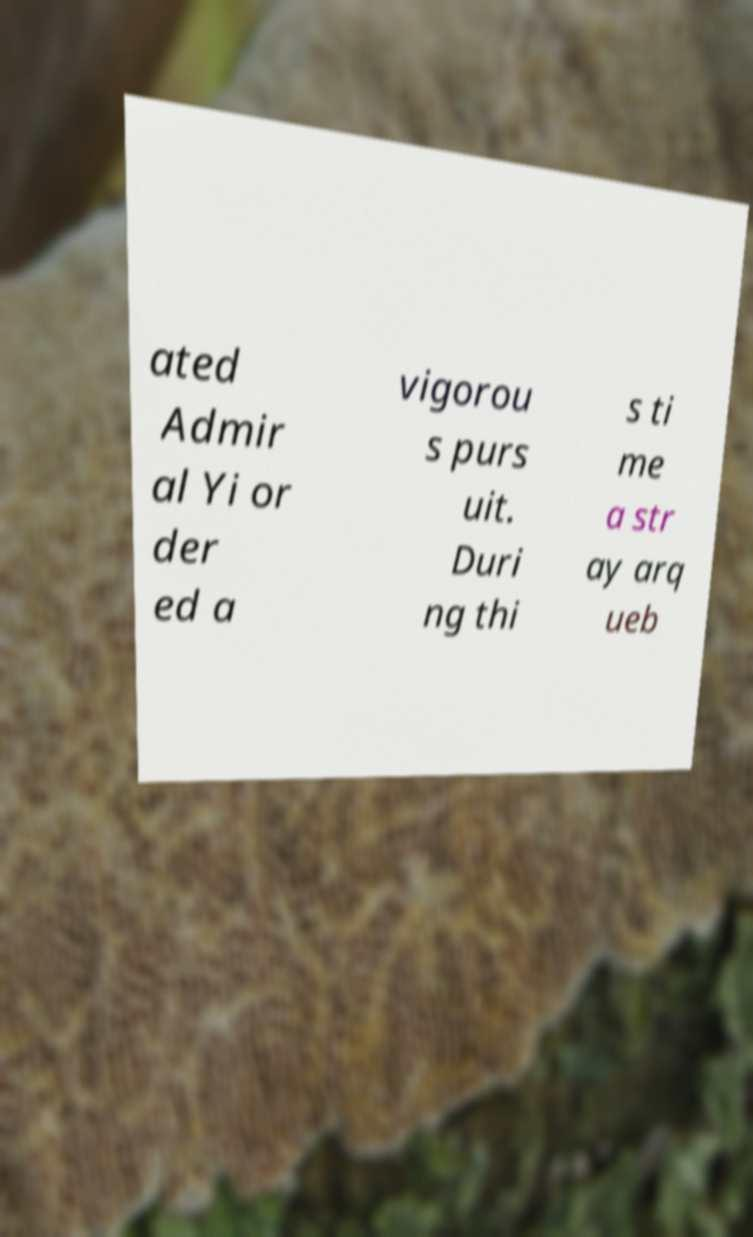Can you accurately transcribe the text from the provided image for me? ated Admir al Yi or der ed a vigorou s purs uit. Duri ng thi s ti me a str ay arq ueb 